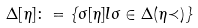Convert formula to latex. <formula><loc_0><loc_0><loc_500><loc_500>\Delta [ \eta ] \colon = \{ \sigma [ \eta ] l \sigma \in \Delta ( \eta { \prec } ) \}</formula> 